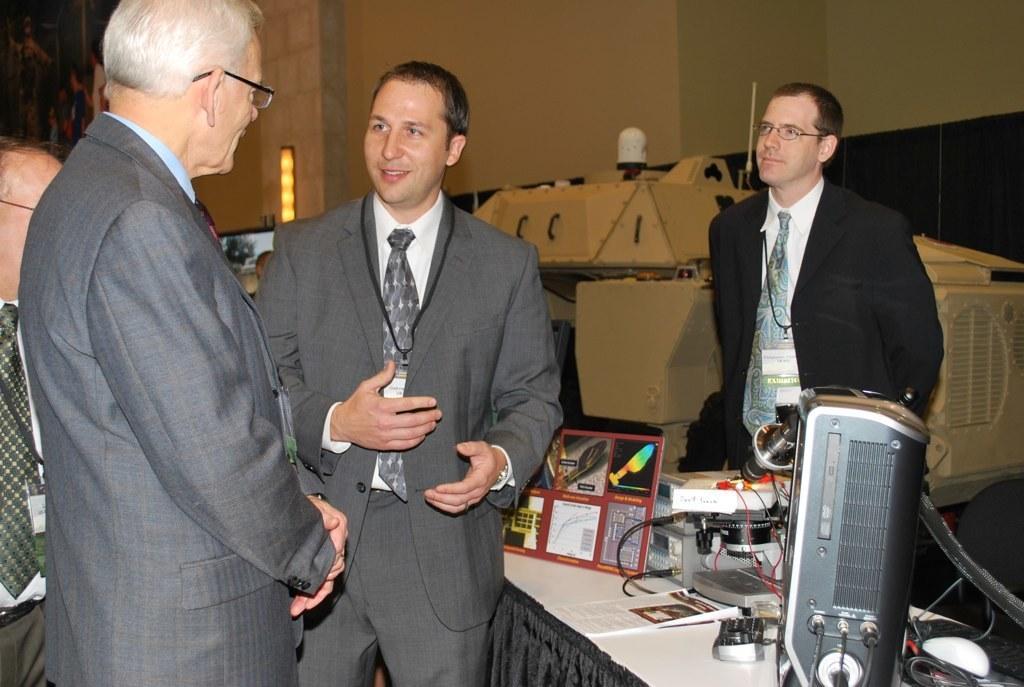Can you describe this image briefly? In this picture I can see a few people wearing suits and standing. I can see electronic devices on the table. I can see the wall in the background. 